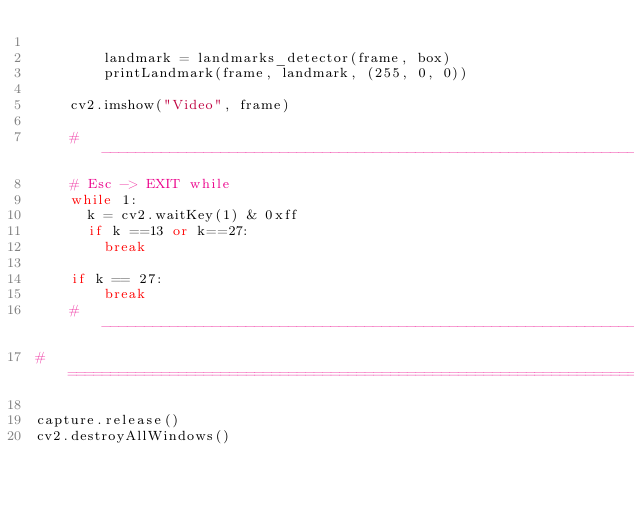<code> <loc_0><loc_0><loc_500><loc_500><_Python_>        
        landmark = landmarks_detector(frame, box)
        printLandmark(frame, landmark, (255, 0, 0))

    cv2.imshow("Video", frame)

    # ------------------------------------------------------------------------------------------------------------------
    # Esc -> EXIT while
    while 1:
      k = cv2.waitKey(1) & 0xff
      if k ==13 or k==27:
        break

    if k == 27:
        break
    # ------------------------------------------------------------------------------------------------------------------
# ====================================================================================================================

capture.release()
cv2.destroyAllWindows()</code> 